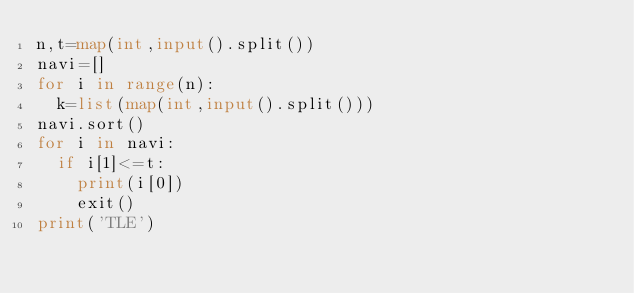Convert code to text. <code><loc_0><loc_0><loc_500><loc_500><_Python_>n,t=map(int,input().split())
navi=[]
for i in range(n):
  k=list(map(int,input().split()))
navi.sort()
for i in navi:
  if i[1]<=t:
    print(i[0])
    exit()
print('TLE')</code> 